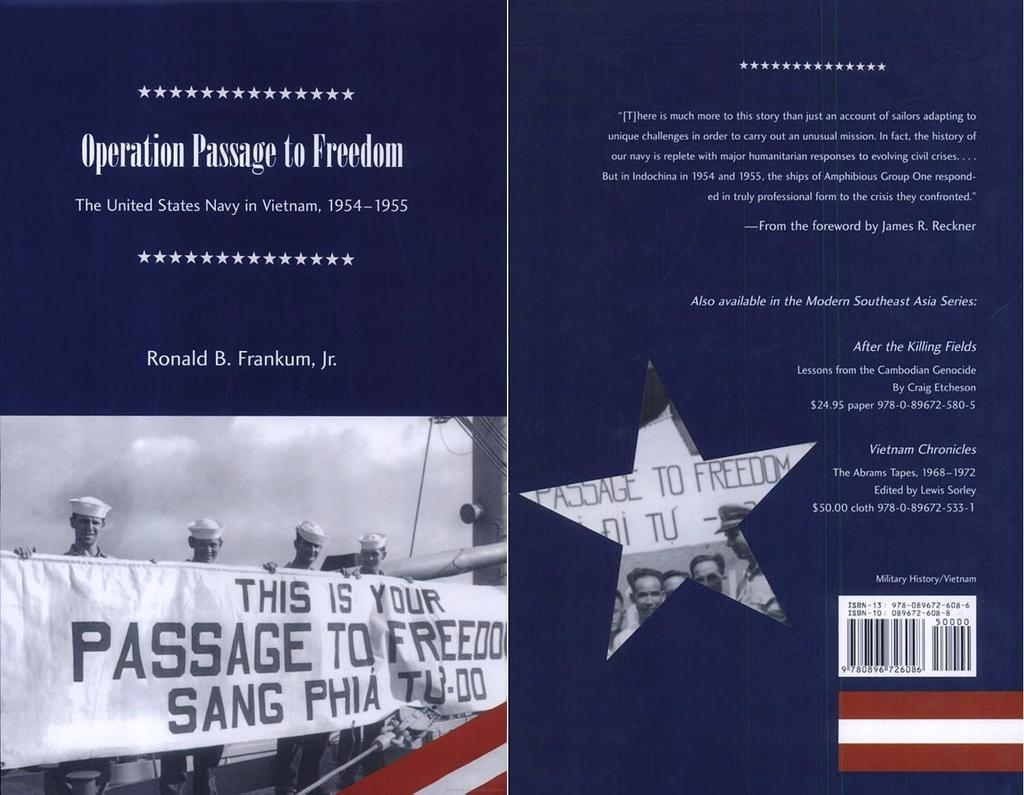What is featured on the poster in the image? There is a poster in the image that contains text and a picture of four persons. What are the four persons doing in the picture on the poster? The four persons are holding a banner in their hands. What can be seen in the background of the image? The sky is visible in the image. Can you see the ducks swimming in the sky in the image? There are no ducks present in the image, and they cannot be seen swimming in the sky. 